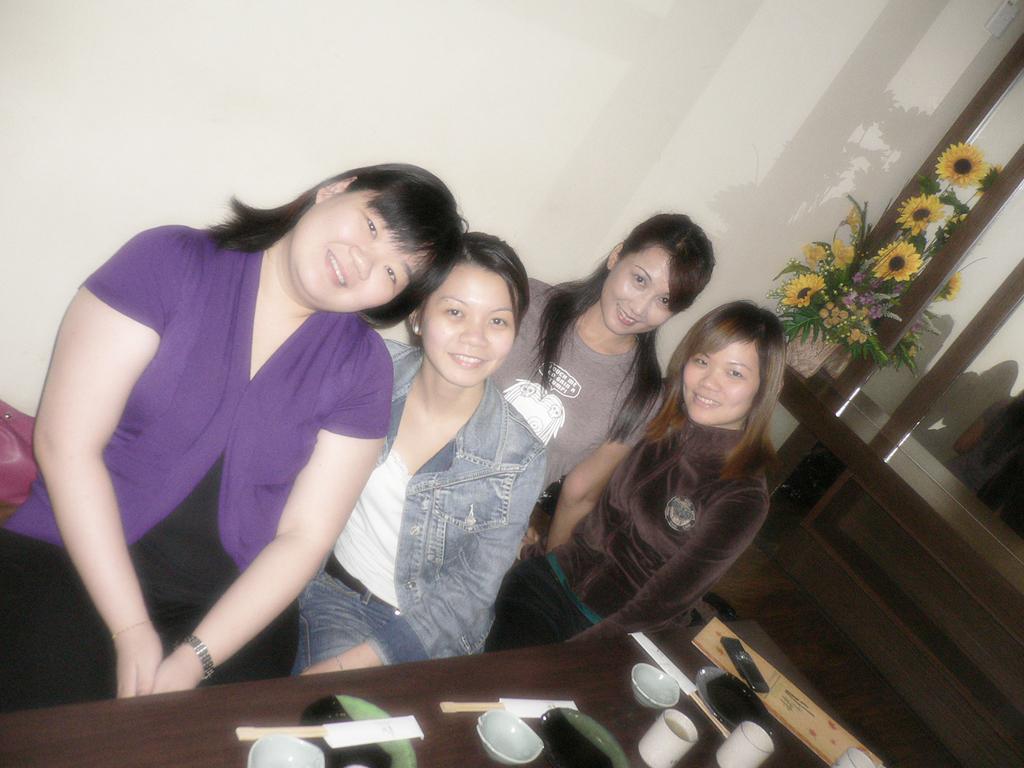How would you summarize this image in a sentence or two? In this image there are few women sitting before a table. On the table there are few plates, bowls, cups, mobile and few objects on it. Right side there is a flower vase on the table. Behind there is a mirror. Background there is a wall. 